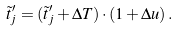Convert formula to latex. <formula><loc_0><loc_0><loc_500><loc_500>\tilde { t } ^ { \prime } _ { j } = ( \tilde { t } ^ { \prime } _ { j } + \Delta T ) \cdot ( 1 + \Delta u ) \, .</formula> 